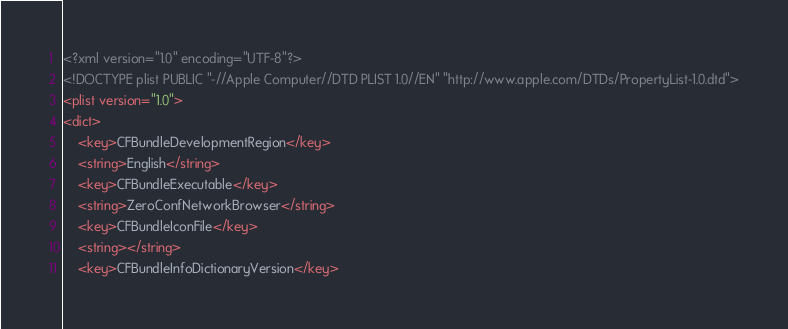Convert code to text. <code><loc_0><loc_0><loc_500><loc_500><_XML_><?xml version="1.0" encoding="UTF-8"?>
<!DOCTYPE plist PUBLIC "-//Apple Computer//DTD PLIST 1.0//EN" "http://www.apple.com/DTDs/PropertyList-1.0.dtd">
<plist version="1.0">
<dict>
	<key>CFBundleDevelopmentRegion</key>
	<string>English</string>
	<key>CFBundleExecutable</key>
	<string>ZeroConfNetworkBrowser</string>
	<key>CFBundleIconFile</key>
	<string></string>
	<key>CFBundleInfoDictionaryVersion</key></code> 